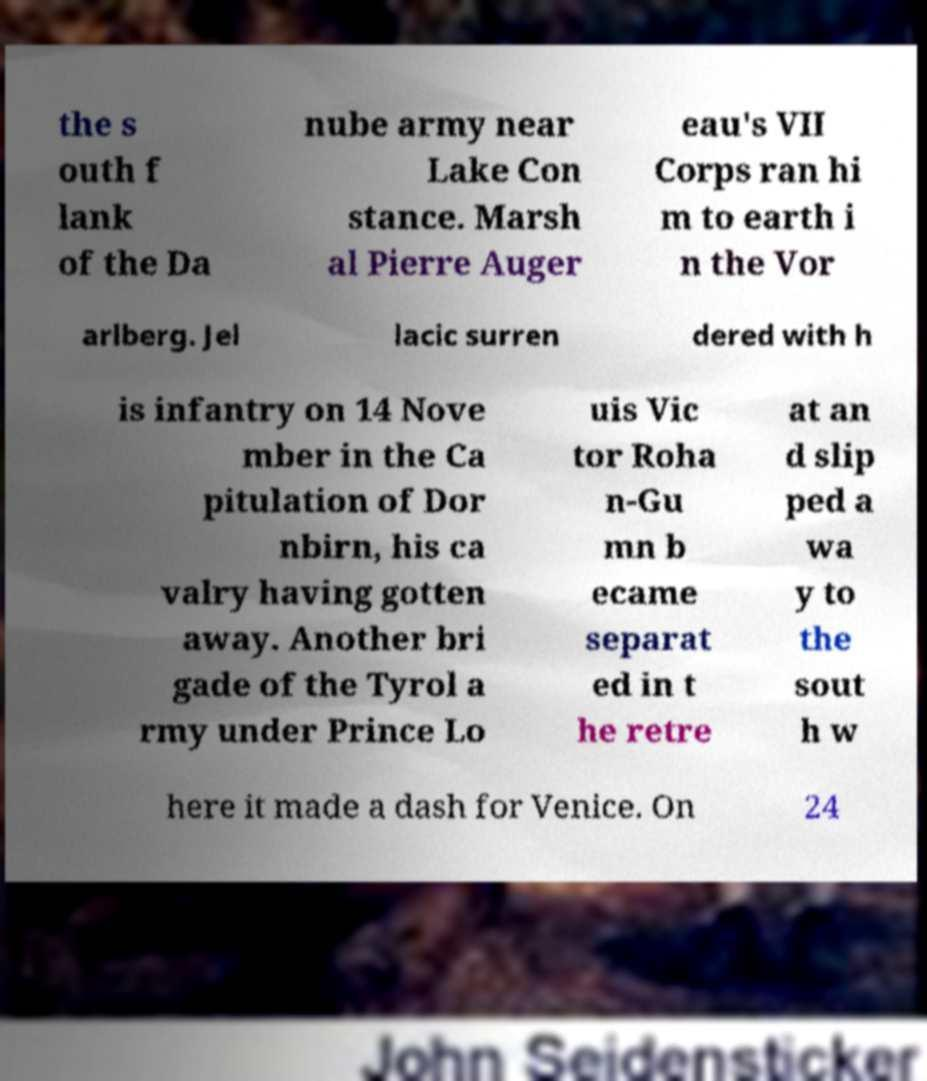Please read and relay the text visible in this image. What does it say? the s outh f lank of the Da nube army near Lake Con stance. Marsh al Pierre Auger eau's VII Corps ran hi m to earth i n the Vor arlberg. Jel lacic surren dered with h is infantry on 14 Nove mber in the Ca pitulation of Dor nbirn, his ca valry having gotten away. Another bri gade of the Tyrol a rmy under Prince Lo uis Vic tor Roha n-Gu mn b ecame separat ed in t he retre at an d slip ped a wa y to the sout h w here it made a dash for Venice. On 24 